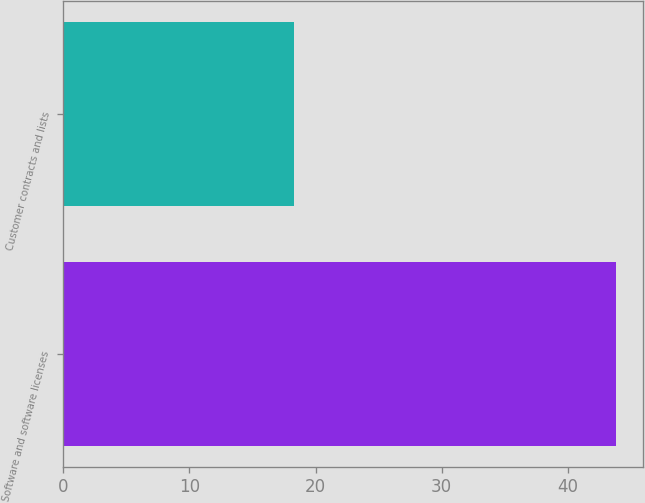Convert chart to OTSL. <chart><loc_0><loc_0><loc_500><loc_500><bar_chart><fcel>Software and software licenses<fcel>Customer contracts and lists<nl><fcel>43.8<fcel>18.3<nl></chart> 